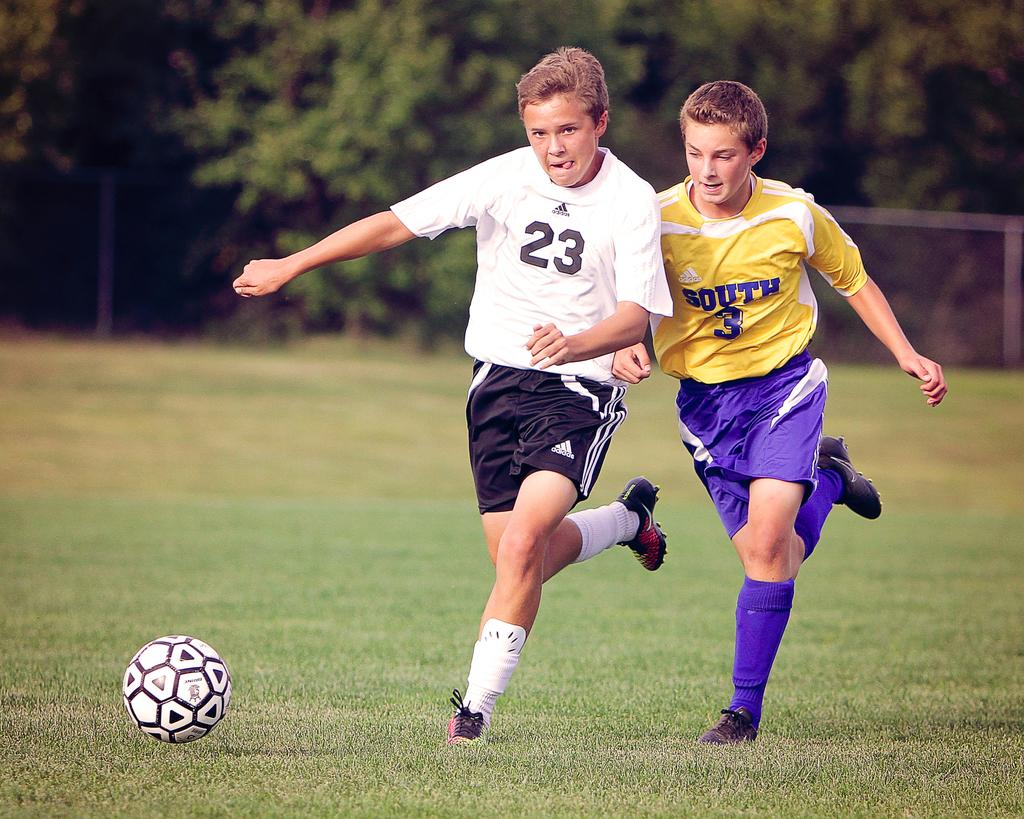<image>
Create a compact narrative representing the image presented. Soccer player wearing number 23 next to one wearing number 3. 